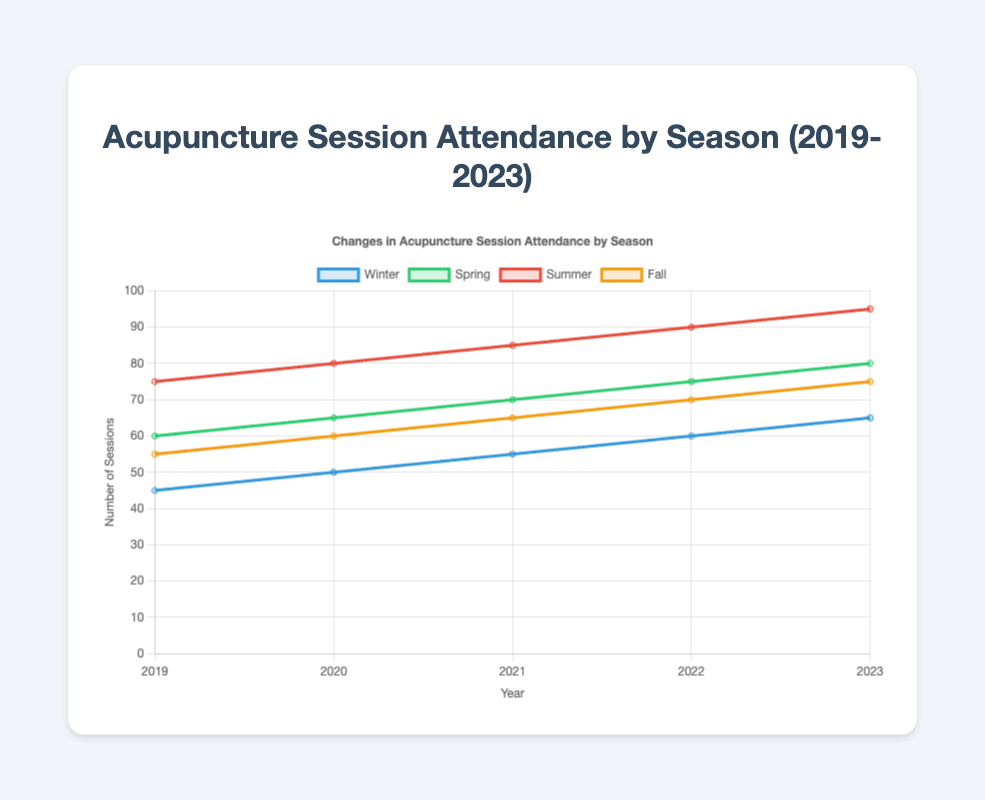What's the average number of sessions attended in Winter for the past five years? First, add up the numbers for Winter from 2019 to 2023: (45 + 50 + 55 + 60 + 65) = 275. Then, divide the total by 5 to get the average: 275 / 5 = 55.
Answer: 55 Which season had the highest attendance in 2021? Compare the number of sessions attended in each season for 2021: Winter (55), Spring (70), Summer (85), and Fall (65). The highest number is in Summer with 85 sessions.
Answer: Summer How many more sessions were attended in Summer compared to Winter in 2022? Subtract the number of Winter sessions in 2022 from the number of Summer sessions in 2022: 90 - 60 = 30.
Answer: 30 In which year did Spring attendance see the biggest increase compared to the previous year? Calculate the differences between consecutive years for Spring: 2020-2019 (65-60 = 5), 2021-2020 (70-65 = 5), 2022-2021 (75-70 = 5), 2023-2022 (80-75 = 5). Since all differences are the same (5), there's no single year with the biggest increase; they all increased by 5.
Answer: No single year What is the trend in Fall attendance from 2019 to 2023? Look at the Fall attendance numbers: 55 (2019), 60 (2020), 65 (2021), 70 (2022), 75 (2023). The numbers show a consistent increase each year.
Answer: Increasing trend Which year had the highest overall attendance across all seasons? Sum the sessions for each year and compare: 2019 (45 + 60 + 75 + 55 = 235), 2020 (50 + 65 + 80 + 60 = 255), 2021 (55 + 70 + 85 + 65 = 275), 2022 (60 + 75 + 90 + 70 = 295), 2023 (65 + 80 + 95 + 75 = 315). The highest total is in 2023.
Answer: 2023 What is the total number of sessions attended in Summer over the past five years? Add the Summer attendance numbers from 2019 to 2023: 75 (2019) + 80 (2020) + 85 (2021) + 90 (2022) + 95 (2023) = 425.
Answer: 425 Which season shows the least variation in attendance over the five years? Calculate the range (max - min) for each season: Winter (65-45=20), Spring (80-60=20), Summer (95-75=20), Fall (75-55=20). Each season has the same range, so they all show the same variation.
Answer: All seasons How does the trend of Winter attendance compare with Spring attendance over the five years? Observe the data: Winter (45, 50, 55, 60, 65) shows a steady increase, and Spring (60, 65, 70, 75, 80) also shows a steady increase. Both seasons have increasing trends.
Answer: Both increasing What is the total increase in attendance for Summer from 2019 to 2023? Subtract the Summer attendance in 2019 from the attendance in 2023: 95 (2023) - 75 (2019) = 20.
Answer: 20 